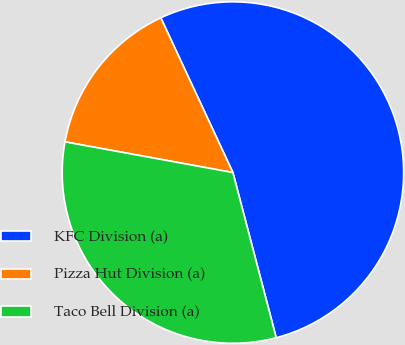Convert chart to OTSL. <chart><loc_0><loc_0><loc_500><loc_500><pie_chart><fcel>KFC Division (a)<fcel>Pizza Hut Division (a)<fcel>Taco Bell Division (a)<nl><fcel>52.86%<fcel>15.18%<fcel>31.96%<nl></chart> 